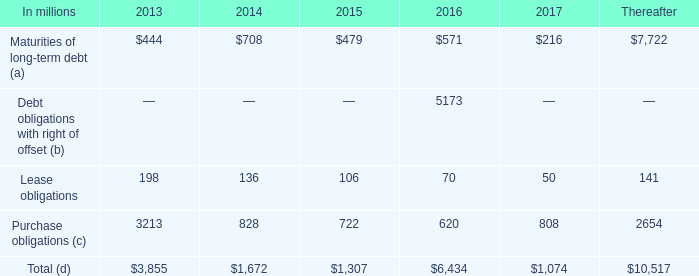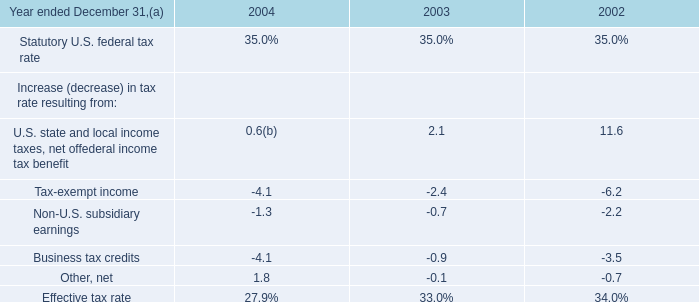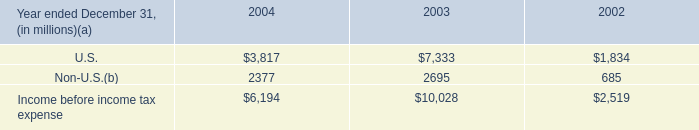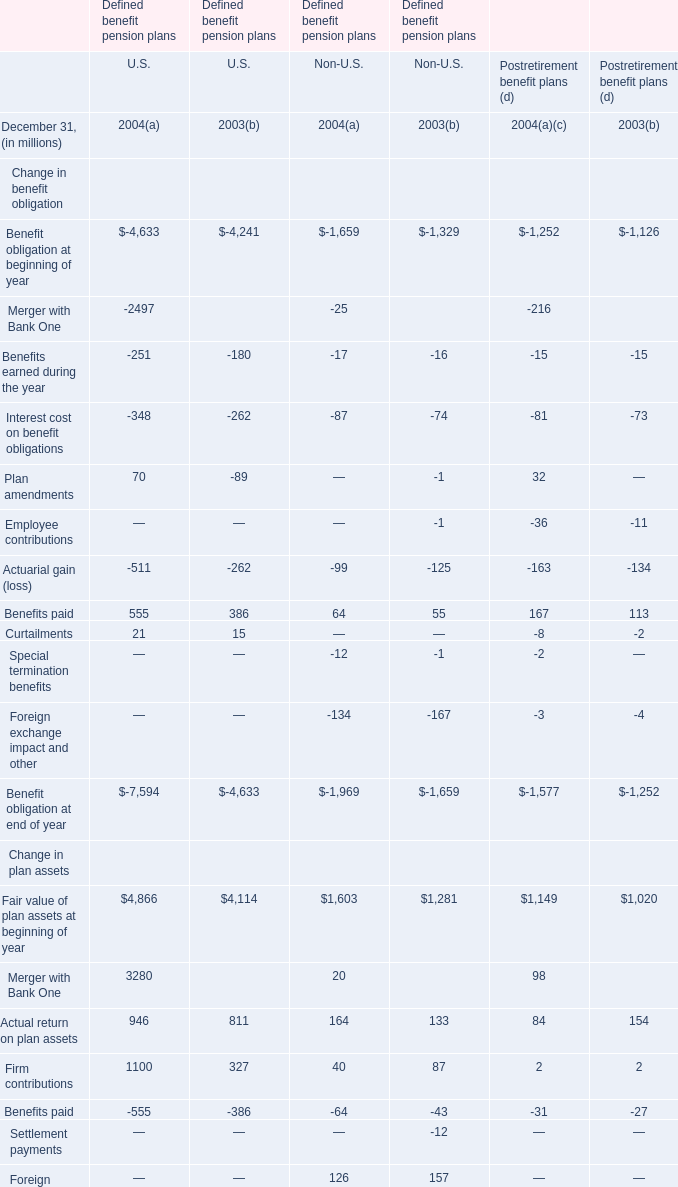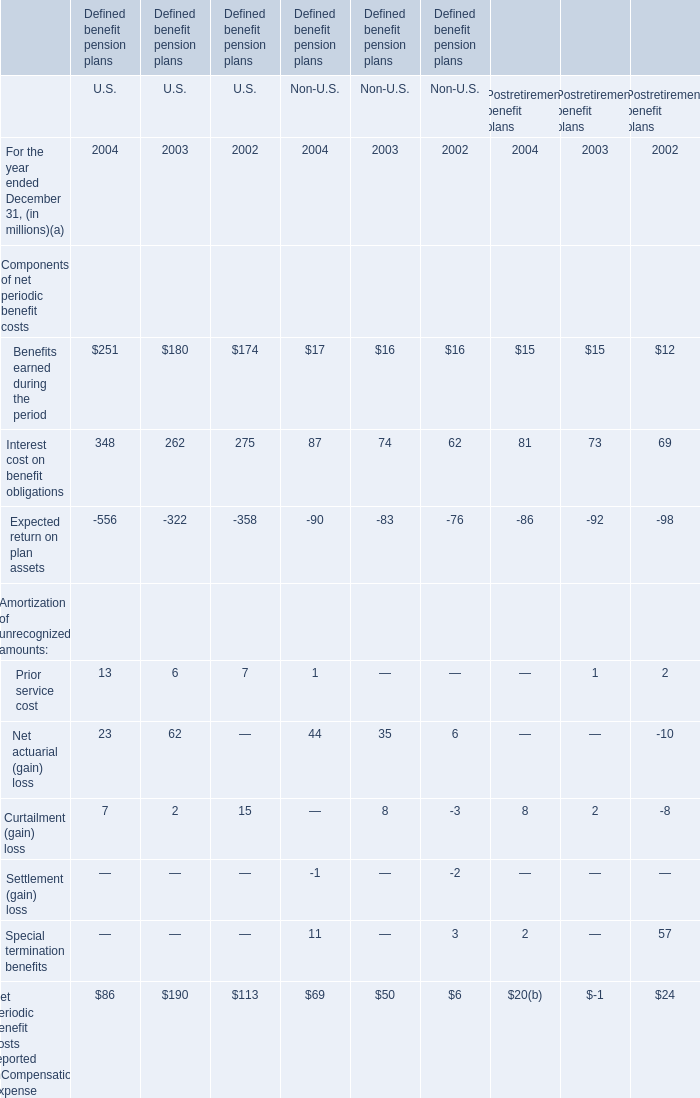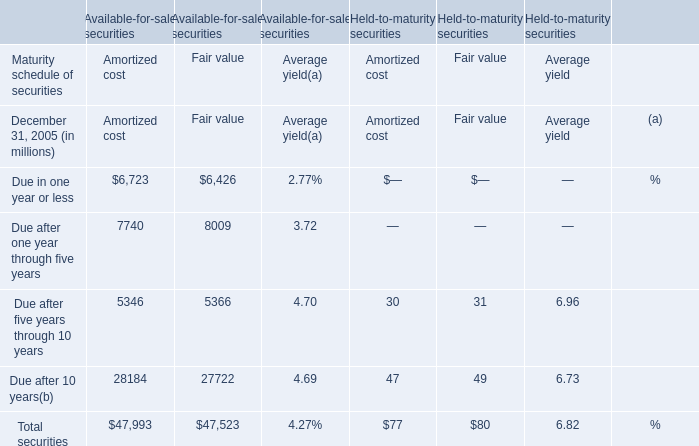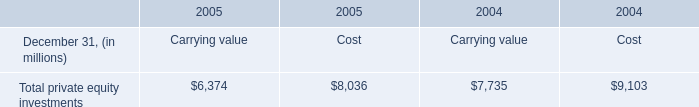what percentage of contractual obligations for future payments under existing debt and lease commitments and purchase obligations at december 31 , 2012 is short term for the year 2014? 
Computations: ((136 + 828) / 1672)
Answer: 0.57656. 